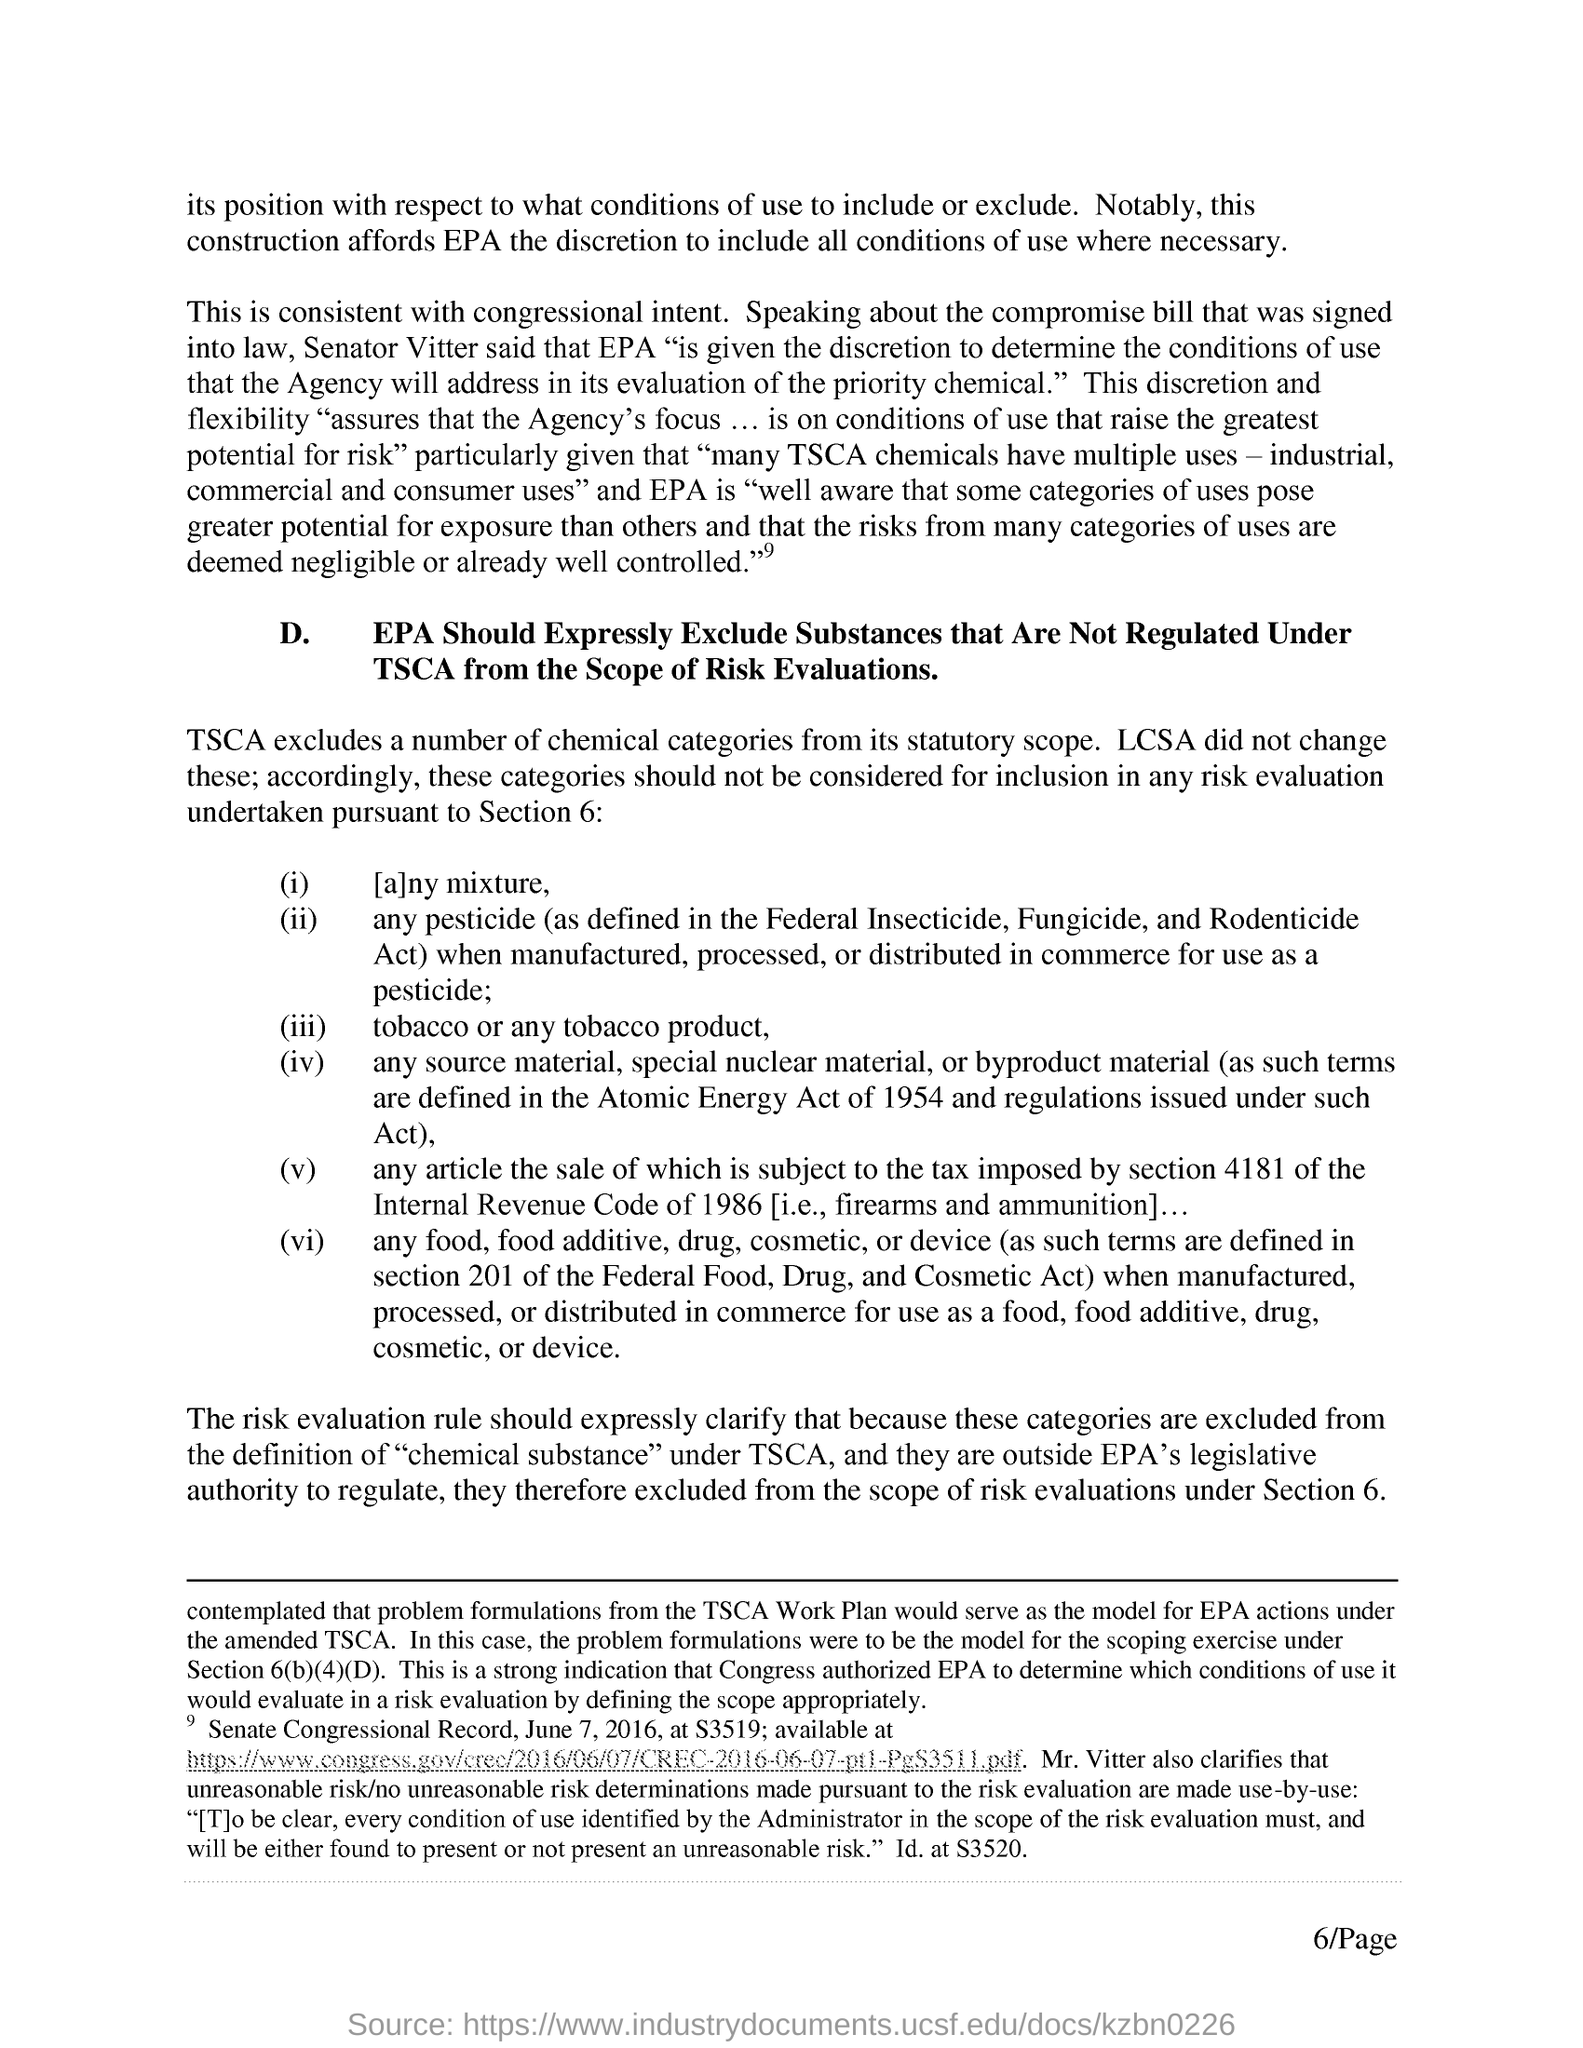Give some essential details in this illustration. The tax is imposed under Section 4181. The Atomic Energy Act came into force in 1954. The sentence can be rephrased as follows:

The Senator Vitter stated that the Environmental Protection Agency (EPA) has been given the authority to determine the conditions of use that it will consider while evaluating the priority chemical. The code related to section 4181 tax is imposed by the Internal Revenue Code. The Toxic Substances Control Act (TSCA) excludes certain chemical categories from its scope. 